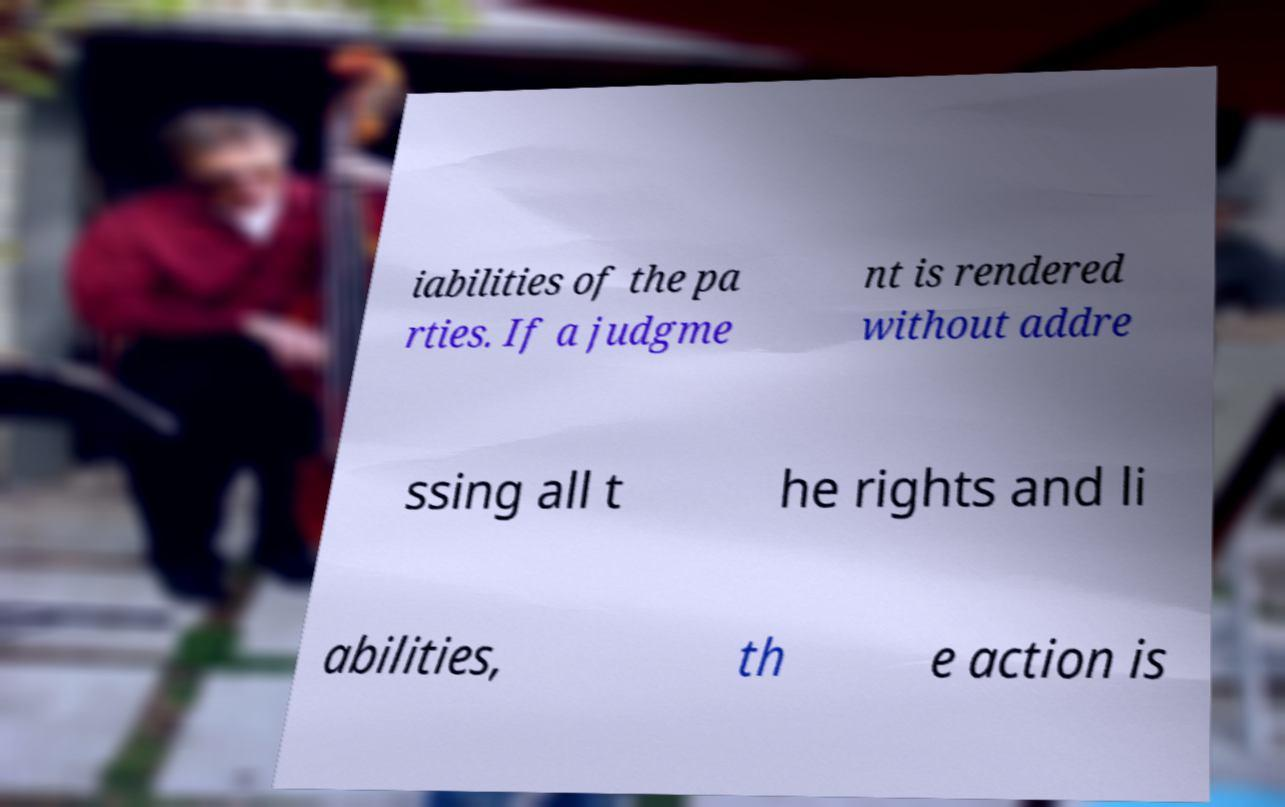Can you accurately transcribe the text from the provided image for me? iabilities of the pa rties. If a judgme nt is rendered without addre ssing all t he rights and li abilities, th e action is 